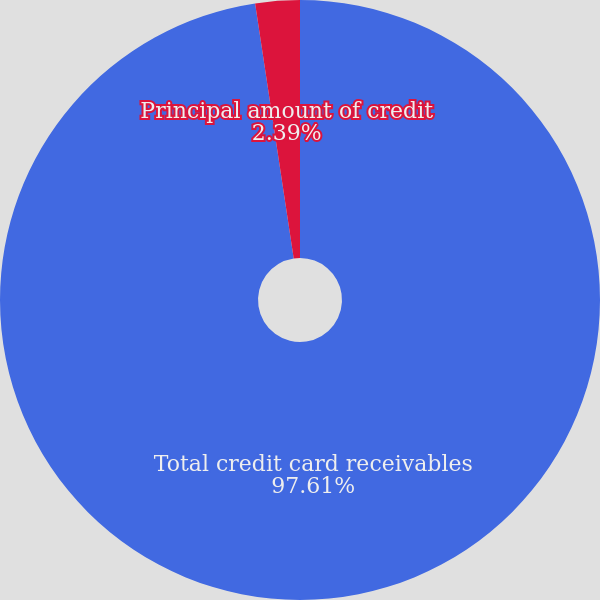Convert chart. <chart><loc_0><loc_0><loc_500><loc_500><pie_chart><fcel>Total credit card receivables<fcel>Principal amount of credit<nl><fcel>97.61%<fcel>2.39%<nl></chart> 